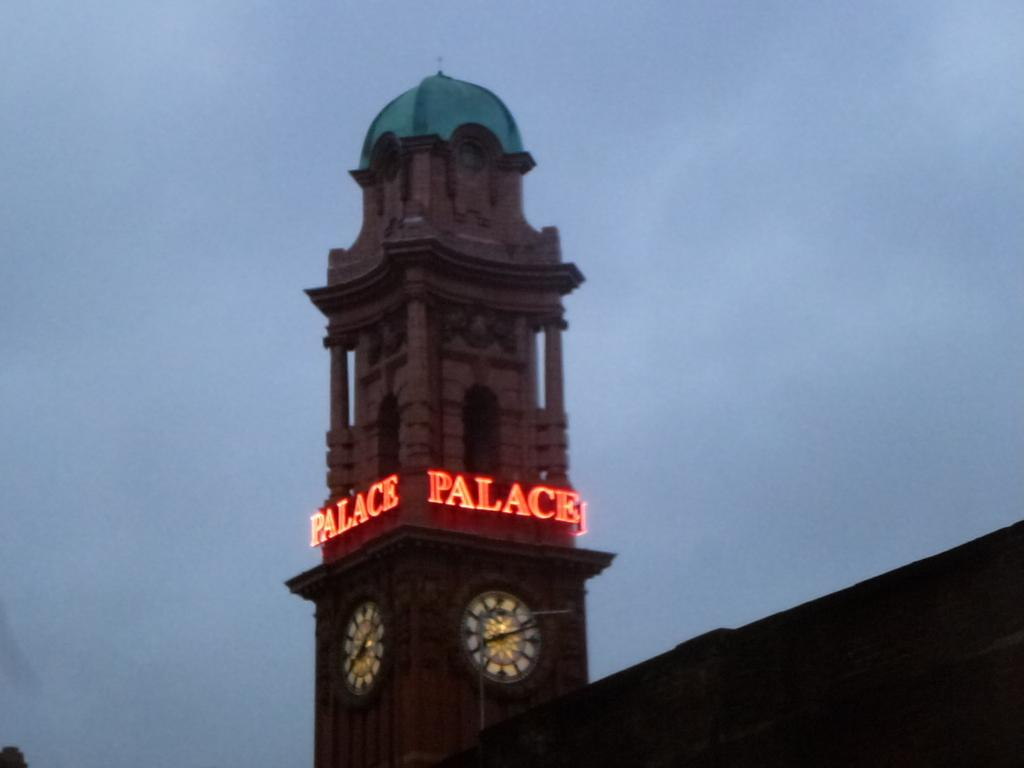<image>
Present a compact description of the photo's key features. Tall building with a clock and the word "Palace" on it. 